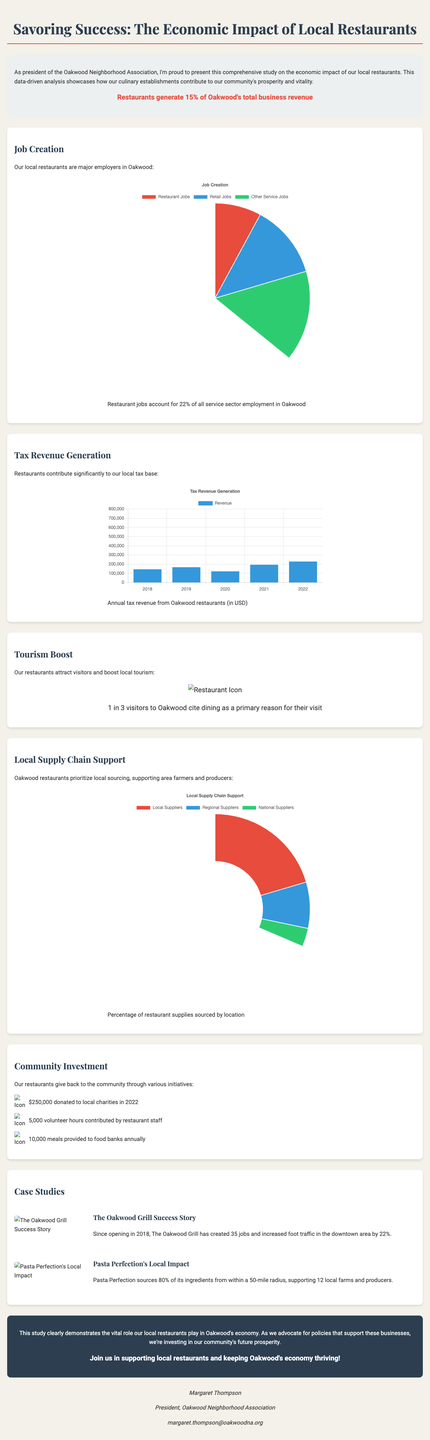What percentage of total business revenue do restaurants generate in Oakwood? The document states that restaurants generate 15% of Oakwood's total business revenue.
Answer: 15% How many jobs do local restaurants account for in the service sector? The infographic indicates that restaurant jobs account for 22% of all service sector employment in Oakwood.
Answer: 22% What was the annual tax revenue from restaurants in 2022? The chart shows that the annual tax revenue from Oakwood restaurants in 2022 was $720,000.
Answer: $720,000 What local sourcing percentage do Oakwood restaurants prioritize? The donut chart illustrates that Oakwood restaurants source 65% of their supplies from local suppliers.
Answer: 65% How many volunteer hours did restaurant staff contribute in 2022? The brochure mentions that restaurant staff contributed 5,000 volunteer hours to the community in 2022.
Answer: 5,000 Which restaurant created 35 jobs since opening in 2018? The case study for The Oakwood Grill specifies that it created 35 jobs since its opening.
Answer: The Oakwood Grill What percentage of visitors cite dining as a primary reason for their visit to Oakwood? The icon chart indicates that 1 in 3 visitors to Oakwood cite dining as a primary reason for their visit, which translates to approximately 33%.
Answer: 1 in 3 How much money did local restaurants donate to charities in 2022? The infographic states that local restaurants donated $250,000 to local charities in 2022.
Answer: $250,000 What is the name of the author of the brochure? The brochure includes information about the author, stating her name is Margaret Thompson.
Answer: Margaret Thompson 